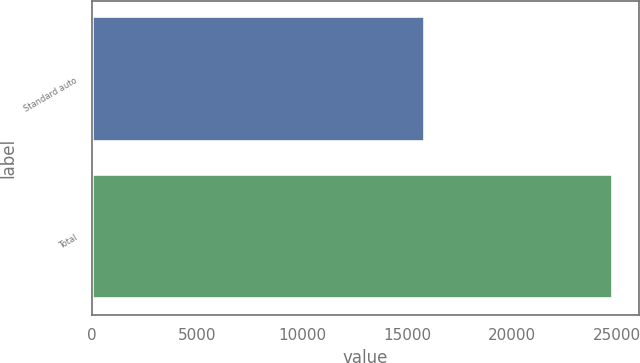Convert chart to OTSL. <chart><loc_0><loc_0><loc_500><loc_500><bar_chart><fcel>Standard auto<fcel>Total<nl><fcel>15842<fcel>24809<nl></chart> 